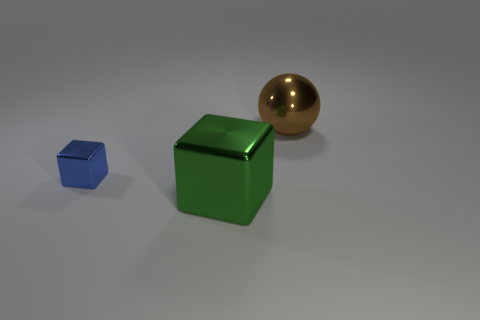What shape is the big object that is on the right side of the big green metallic block?
Offer a very short reply. Sphere. Is there a large cube that has the same color as the big ball?
Keep it short and to the point. No. Does the block left of the green cube have the same size as the object on the right side of the big green shiny object?
Provide a succinct answer. No. Is the number of brown objects that are in front of the blue block greater than the number of large green objects to the left of the sphere?
Make the answer very short. No. Is there another big green thing that has the same material as the big green thing?
Provide a short and direct response. No. Do the shiny sphere and the tiny metal thing have the same color?
Keep it short and to the point. No. What is the thing that is in front of the sphere and right of the small blue thing made of?
Your answer should be compact. Metal. What is the color of the tiny metal thing?
Offer a terse response. Blue. What number of large green shiny things are the same shape as the blue thing?
Your response must be concise. 1. Do the big thing that is to the left of the brown thing and the sphere to the right of the small blue cube have the same material?
Your response must be concise. Yes. 